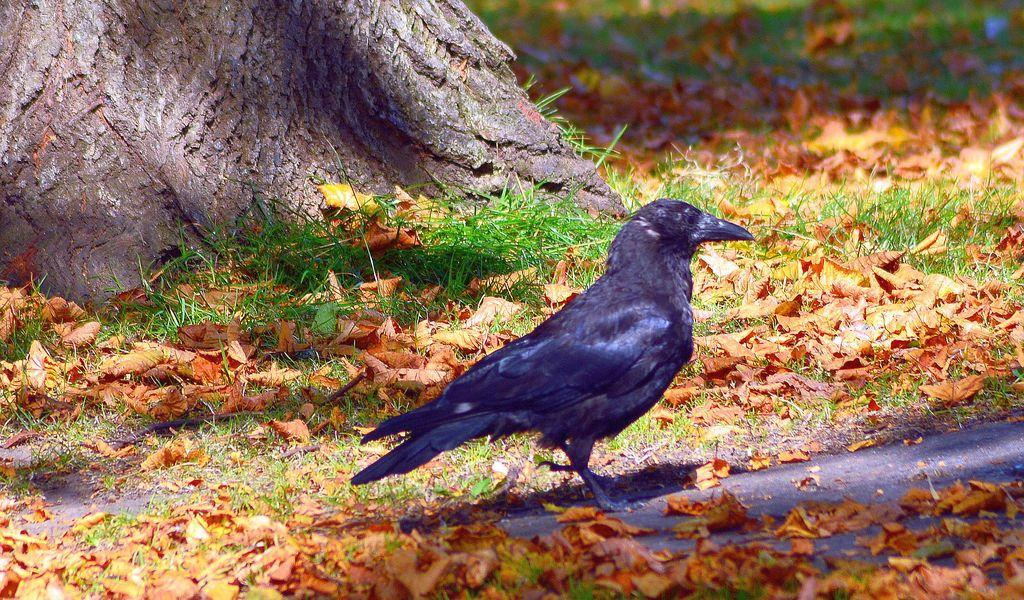What is the main subject in the center of the image? There is a bird in the center of the image. Where is the bird located? The bird is on the ground. What else can be seen on the ground in the image? There are dry leaves on the ground. What can be seen in the background of the image? There is grass and a tree in the background of the image. What type of cork can be seen in the image? There is no cork present in the image. How does the bird twist its body in the image? The bird is not shown twisting its body in the image; it is simply standing on the ground. 